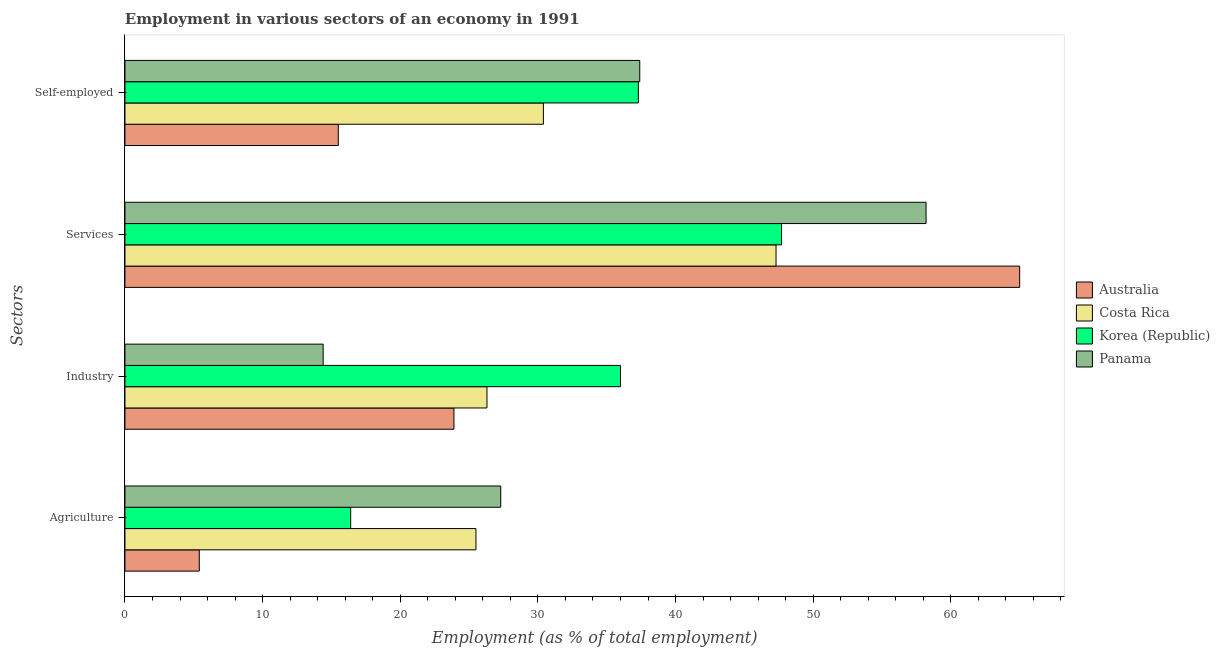How many different coloured bars are there?
Offer a terse response. 4. How many groups of bars are there?
Provide a short and direct response. 4. Are the number of bars on each tick of the Y-axis equal?
Your answer should be compact. Yes. How many bars are there on the 1st tick from the top?
Your response must be concise. 4. How many bars are there on the 1st tick from the bottom?
Your response must be concise. 4. What is the label of the 1st group of bars from the top?
Offer a very short reply. Self-employed. What is the percentage of self employed workers in Panama?
Your response must be concise. 37.4. In which country was the percentage of workers in industry minimum?
Provide a succinct answer. Panama. What is the total percentage of workers in agriculture in the graph?
Your response must be concise. 74.6. What is the difference between the percentage of workers in services in Australia and that in Korea (Republic)?
Your answer should be compact. 17.3. What is the difference between the percentage of workers in services in Costa Rica and the percentage of workers in industry in Australia?
Make the answer very short. 23.4. What is the average percentage of workers in industry per country?
Your response must be concise. 25.15. What is the difference between the percentage of workers in agriculture and percentage of workers in industry in Korea (Republic)?
Ensure brevity in your answer.  -19.6. What is the ratio of the percentage of workers in industry in Australia to that in Korea (Republic)?
Your response must be concise. 0.66. Is the percentage of workers in agriculture in Costa Rica less than that in Australia?
Your answer should be compact. No. Is the difference between the percentage of self employed workers in Australia and Costa Rica greater than the difference between the percentage of workers in agriculture in Australia and Costa Rica?
Ensure brevity in your answer.  Yes. What is the difference between the highest and the second highest percentage of workers in services?
Ensure brevity in your answer.  6.8. What is the difference between the highest and the lowest percentage of workers in industry?
Ensure brevity in your answer.  21.6. What does the 3rd bar from the top in Agriculture represents?
Your answer should be compact. Costa Rica. How many bars are there?
Provide a short and direct response. 16. Are the values on the major ticks of X-axis written in scientific E-notation?
Provide a short and direct response. No. How many legend labels are there?
Offer a terse response. 4. What is the title of the graph?
Your answer should be compact. Employment in various sectors of an economy in 1991. Does "Iran" appear as one of the legend labels in the graph?
Your answer should be compact. No. What is the label or title of the X-axis?
Offer a very short reply. Employment (as % of total employment). What is the label or title of the Y-axis?
Keep it short and to the point. Sectors. What is the Employment (as % of total employment) of Australia in Agriculture?
Provide a short and direct response. 5.4. What is the Employment (as % of total employment) of Costa Rica in Agriculture?
Provide a short and direct response. 25.5. What is the Employment (as % of total employment) of Korea (Republic) in Agriculture?
Your answer should be very brief. 16.4. What is the Employment (as % of total employment) of Panama in Agriculture?
Offer a very short reply. 27.3. What is the Employment (as % of total employment) in Australia in Industry?
Offer a very short reply. 23.9. What is the Employment (as % of total employment) of Costa Rica in Industry?
Provide a short and direct response. 26.3. What is the Employment (as % of total employment) of Korea (Republic) in Industry?
Your answer should be compact. 36. What is the Employment (as % of total employment) of Panama in Industry?
Offer a very short reply. 14.4. What is the Employment (as % of total employment) in Australia in Services?
Your answer should be compact. 65. What is the Employment (as % of total employment) of Costa Rica in Services?
Make the answer very short. 47.3. What is the Employment (as % of total employment) in Korea (Republic) in Services?
Offer a very short reply. 47.7. What is the Employment (as % of total employment) in Panama in Services?
Your response must be concise. 58.2. What is the Employment (as % of total employment) of Australia in Self-employed?
Your response must be concise. 15.5. What is the Employment (as % of total employment) of Costa Rica in Self-employed?
Keep it short and to the point. 30.4. What is the Employment (as % of total employment) in Korea (Republic) in Self-employed?
Ensure brevity in your answer.  37.3. What is the Employment (as % of total employment) of Panama in Self-employed?
Ensure brevity in your answer.  37.4. Across all Sectors, what is the maximum Employment (as % of total employment) in Costa Rica?
Offer a terse response. 47.3. Across all Sectors, what is the maximum Employment (as % of total employment) in Korea (Republic)?
Give a very brief answer. 47.7. Across all Sectors, what is the maximum Employment (as % of total employment) of Panama?
Keep it short and to the point. 58.2. Across all Sectors, what is the minimum Employment (as % of total employment) of Australia?
Offer a terse response. 5.4. Across all Sectors, what is the minimum Employment (as % of total employment) in Costa Rica?
Provide a short and direct response. 25.5. Across all Sectors, what is the minimum Employment (as % of total employment) of Korea (Republic)?
Keep it short and to the point. 16.4. Across all Sectors, what is the minimum Employment (as % of total employment) of Panama?
Offer a very short reply. 14.4. What is the total Employment (as % of total employment) of Australia in the graph?
Make the answer very short. 109.8. What is the total Employment (as % of total employment) of Costa Rica in the graph?
Provide a short and direct response. 129.5. What is the total Employment (as % of total employment) of Korea (Republic) in the graph?
Your response must be concise. 137.4. What is the total Employment (as % of total employment) in Panama in the graph?
Offer a very short reply. 137.3. What is the difference between the Employment (as % of total employment) of Australia in Agriculture and that in Industry?
Your response must be concise. -18.5. What is the difference between the Employment (as % of total employment) of Costa Rica in Agriculture and that in Industry?
Ensure brevity in your answer.  -0.8. What is the difference between the Employment (as % of total employment) in Korea (Republic) in Agriculture and that in Industry?
Keep it short and to the point. -19.6. What is the difference between the Employment (as % of total employment) in Panama in Agriculture and that in Industry?
Make the answer very short. 12.9. What is the difference between the Employment (as % of total employment) of Australia in Agriculture and that in Services?
Your response must be concise. -59.6. What is the difference between the Employment (as % of total employment) of Costa Rica in Agriculture and that in Services?
Provide a succinct answer. -21.8. What is the difference between the Employment (as % of total employment) in Korea (Republic) in Agriculture and that in Services?
Your answer should be compact. -31.3. What is the difference between the Employment (as % of total employment) of Panama in Agriculture and that in Services?
Ensure brevity in your answer.  -30.9. What is the difference between the Employment (as % of total employment) in Australia in Agriculture and that in Self-employed?
Keep it short and to the point. -10.1. What is the difference between the Employment (as % of total employment) of Korea (Republic) in Agriculture and that in Self-employed?
Make the answer very short. -20.9. What is the difference between the Employment (as % of total employment) of Australia in Industry and that in Services?
Offer a very short reply. -41.1. What is the difference between the Employment (as % of total employment) in Panama in Industry and that in Services?
Your answer should be compact. -43.8. What is the difference between the Employment (as % of total employment) in Panama in Industry and that in Self-employed?
Give a very brief answer. -23. What is the difference between the Employment (as % of total employment) of Australia in Services and that in Self-employed?
Your response must be concise. 49.5. What is the difference between the Employment (as % of total employment) of Korea (Republic) in Services and that in Self-employed?
Ensure brevity in your answer.  10.4. What is the difference between the Employment (as % of total employment) of Panama in Services and that in Self-employed?
Provide a succinct answer. 20.8. What is the difference between the Employment (as % of total employment) of Australia in Agriculture and the Employment (as % of total employment) of Costa Rica in Industry?
Give a very brief answer. -20.9. What is the difference between the Employment (as % of total employment) in Australia in Agriculture and the Employment (as % of total employment) in Korea (Republic) in Industry?
Give a very brief answer. -30.6. What is the difference between the Employment (as % of total employment) in Australia in Agriculture and the Employment (as % of total employment) in Panama in Industry?
Offer a terse response. -9. What is the difference between the Employment (as % of total employment) in Costa Rica in Agriculture and the Employment (as % of total employment) in Panama in Industry?
Provide a succinct answer. 11.1. What is the difference between the Employment (as % of total employment) in Korea (Republic) in Agriculture and the Employment (as % of total employment) in Panama in Industry?
Your response must be concise. 2. What is the difference between the Employment (as % of total employment) in Australia in Agriculture and the Employment (as % of total employment) in Costa Rica in Services?
Provide a short and direct response. -41.9. What is the difference between the Employment (as % of total employment) in Australia in Agriculture and the Employment (as % of total employment) in Korea (Republic) in Services?
Give a very brief answer. -42.3. What is the difference between the Employment (as % of total employment) of Australia in Agriculture and the Employment (as % of total employment) of Panama in Services?
Provide a succinct answer. -52.8. What is the difference between the Employment (as % of total employment) of Costa Rica in Agriculture and the Employment (as % of total employment) of Korea (Republic) in Services?
Offer a terse response. -22.2. What is the difference between the Employment (as % of total employment) of Costa Rica in Agriculture and the Employment (as % of total employment) of Panama in Services?
Your response must be concise. -32.7. What is the difference between the Employment (as % of total employment) in Korea (Republic) in Agriculture and the Employment (as % of total employment) in Panama in Services?
Make the answer very short. -41.8. What is the difference between the Employment (as % of total employment) in Australia in Agriculture and the Employment (as % of total employment) in Korea (Republic) in Self-employed?
Your answer should be compact. -31.9. What is the difference between the Employment (as % of total employment) of Australia in Agriculture and the Employment (as % of total employment) of Panama in Self-employed?
Your response must be concise. -32. What is the difference between the Employment (as % of total employment) of Costa Rica in Agriculture and the Employment (as % of total employment) of Korea (Republic) in Self-employed?
Offer a very short reply. -11.8. What is the difference between the Employment (as % of total employment) in Costa Rica in Agriculture and the Employment (as % of total employment) in Panama in Self-employed?
Offer a terse response. -11.9. What is the difference between the Employment (as % of total employment) of Korea (Republic) in Agriculture and the Employment (as % of total employment) of Panama in Self-employed?
Provide a short and direct response. -21. What is the difference between the Employment (as % of total employment) of Australia in Industry and the Employment (as % of total employment) of Costa Rica in Services?
Ensure brevity in your answer.  -23.4. What is the difference between the Employment (as % of total employment) of Australia in Industry and the Employment (as % of total employment) of Korea (Republic) in Services?
Your response must be concise. -23.8. What is the difference between the Employment (as % of total employment) in Australia in Industry and the Employment (as % of total employment) in Panama in Services?
Keep it short and to the point. -34.3. What is the difference between the Employment (as % of total employment) in Costa Rica in Industry and the Employment (as % of total employment) in Korea (Republic) in Services?
Provide a succinct answer. -21.4. What is the difference between the Employment (as % of total employment) of Costa Rica in Industry and the Employment (as % of total employment) of Panama in Services?
Your answer should be compact. -31.9. What is the difference between the Employment (as % of total employment) in Korea (Republic) in Industry and the Employment (as % of total employment) in Panama in Services?
Give a very brief answer. -22.2. What is the difference between the Employment (as % of total employment) of Australia in Industry and the Employment (as % of total employment) of Costa Rica in Self-employed?
Give a very brief answer. -6.5. What is the difference between the Employment (as % of total employment) in Australia in Industry and the Employment (as % of total employment) in Korea (Republic) in Self-employed?
Your response must be concise. -13.4. What is the difference between the Employment (as % of total employment) of Costa Rica in Industry and the Employment (as % of total employment) of Korea (Republic) in Self-employed?
Keep it short and to the point. -11. What is the difference between the Employment (as % of total employment) in Korea (Republic) in Industry and the Employment (as % of total employment) in Panama in Self-employed?
Your answer should be compact. -1.4. What is the difference between the Employment (as % of total employment) of Australia in Services and the Employment (as % of total employment) of Costa Rica in Self-employed?
Your answer should be compact. 34.6. What is the difference between the Employment (as % of total employment) of Australia in Services and the Employment (as % of total employment) of Korea (Republic) in Self-employed?
Offer a very short reply. 27.7. What is the difference between the Employment (as % of total employment) in Australia in Services and the Employment (as % of total employment) in Panama in Self-employed?
Your answer should be compact. 27.6. What is the difference between the Employment (as % of total employment) of Costa Rica in Services and the Employment (as % of total employment) of Panama in Self-employed?
Give a very brief answer. 9.9. What is the average Employment (as % of total employment) in Australia per Sectors?
Keep it short and to the point. 27.45. What is the average Employment (as % of total employment) of Costa Rica per Sectors?
Ensure brevity in your answer.  32.38. What is the average Employment (as % of total employment) in Korea (Republic) per Sectors?
Provide a short and direct response. 34.35. What is the average Employment (as % of total employment) in Panama per Sectors?
Your answer should be compact. 34.33. What is the difference between the Employment (as % of total employment) in Australia and Employment (as % of total employment) in Costa Rica in Agriculture?
Your answer should be very brief. -20.1. What is the difference between the Employment (as % of total employment) in Australia and Employment (as % of total employment) in Korea (Republic) in Agriculture?
Offer a terse response. -11. What is the difference between the Employment (as % of total employment) of Australia and Employment (as % of total employment) of Panama in Agriculture?
Make the answer very short. -21.9. What is the difference between the Employment (as % of total employment) of Costa Rica and Employment (as % of total employment) of Korea (Republic) in Agriculture?
Provide a succinct answer. 9.1. What is the difference between the Employment (as % of total employment) of Costa Rica and Employment (as % of total employment) of Panama in Agriculture?
Provide a succinct answer. -1.8. What is the difference between the Employment (as % of total employment) of Australia and Employment (as % of total employment) of Costa Rica in Industry?
Keep it short and to the point. -2.4. What is the difference between the Employment (as % of total employment) of Australia and Employment (as % of total employment) of Korea (Republic) in Industry?
Provide a short and direct response. -12.1. What is the difference between the Employment (as % of total employment) in Australia and Employment (as % of total employment) in Panama in Industry?
Keep it short and to the point. 9.5. What is the difference between the Employment (as % of total employment) of Costa Rica and Employment (as % of total employment) of Panama in Industry?
Ensure brevity in your answer.  11.9. What is the difference between the Employment (as % of total employment) in Korea (Republic) and Employment (as % of total employment) in Panama in Industry?
Keep it short and to the point. 21.6. What is the difference between the Employment (as % of total employment) in Australia and Employment (as % of total employment) in Costa Rica in Services?
Keep it short and to the point. 17.7. What is the difference between the Employment (as % of total employment) in Australia and Employment (as % of total employment) in Korea (Republic) in Services?
Make the answer very short. 17.3. What is the difference between the Employment (as % of total employment) in Australia and Employment (as % of total employment) in Panama in Services?
Your answer should be compact. 6.8. What is the difference between the Employment (as % of total employment) in Costa Rica and Employment (as % of total employment) in Korea (Republic) in Services?
Ensure brevity in your answer.  -0.4. What is the difference between the Employment (as % of total employment) of Costa Rica and Employment (as % of total employment) of Panama in Services?
Offer a terse response. -10.9. What is the difference between the Employment (as % of total employment) of Korea (Republic) and Employment (as % of total employment) of Panama in Services?
Make the answer very short. -10.5. What is the difference between the Employment (as % of total employment) of Australia and Employment (as % of total employment) of Costa Rica in Self-employed?
Give a very brief answer. -14.9. What is the difference between the Employment (as % of total employment) in Australia and Employment (as % of total employment) in Korea (Republic) in Self-employed?
Offer a very short reply. -21.8. What is the difference between the Employment (as % of total employment) in Australia and Employment (as % of total employment) in Panama in Self-employed?
Provide a short and direct response. -21.9. What is the difference between the Employment (as % of total employment) of Costa Rica and Employment (as % of total employment) of Panama in Self-employed?
Provide a short and direct response. -7. What is the ratio of the Employment (as % of total employment) of Australia in Agriculture to that in Industry?
Provide a short and direct response. 0.23. What is the ratio of the Employment (as % of total employment) of Costa Rica in Agriculture to that in Industry?
Make the answer very short. 0.97. What is the ratio of the Employment (as % of total employment) in Korea (Republic) in Agriculture to that in Industry?
Your response must be concise. 0.46. What is the ratio of the Employment (as % of total employment) of Panama in Agriculture to that in Industry?
Ensure brevity in your answer.  1.9. What is the ratio of the Employment (as % of total employment) of Australia in Agriculture to that in Services?
Offer a very short reply. 0.08. What is the ratio of the Employment (as % of total employment) of Costa Rica in Agriculture to that in Services?
Your answer should be very brief. 0.54. What is the ratio of the Employment (as % of total employment) in Korea (Republic) in Agriculture to that in Services?
Make the answer very short. 0.34. What is the ratio of the Employment (as % of total employment) in Panama in Agriculture to that in Services?
Your response must be concise. 0.47. What is the ratio of the Employment (as % of total employment) in Australia in Agriculture to that in Self-employed?
Your response must be concise. 0.35. What is the ratio of the Employment (as % of total employment) of Costa Rica in Agriculture to that in Self-employed?
Your response must be concise. 0.84. What is the ratio of the Employment (as % of total employment) of Korea (Republic) in Agriculture to that in Self-employed?
Offer a very short reply. 0.44. What is the ratio of the Employment (as % of total employment) in Panama in Agriculture to that in Self-employed?
Offer a very short reply. 0.73. What is the ratio of the Employment (as % of total employment) of Australia in Industry to that in Services?
Offer a very short reply. 0.37. What is the ratio of the Employment (as % of total employment) of Costa Rica in Industry to that in Services?
Provide a succinct answer. 0.56. What is the ratio of the Employment (as % of total employment) in Korea (Republic) in Industry to that in Services?
Your response must be concise. 0.75. What is the ratio of the Employment (as % of total employment) of Panama in Industry to that in Services?
Make the answer very short. 0.25. What is the ratio of the Employment (as % of total employment) in Australia in Industry to that in Self-employed?
Offer a terse response. 1.54. What is the ratio of the Employment (as % of total employment) of Costa Rica in Industry to that in Self-employed?
Ensure brevity in your answer.  0.87. What is the ratio of the Employment (as % of total employment) in Korea (Republic) in Industry to that in Self-employed?
Your response must be concise. 0.97. What is the ratio of the Employment (as % of total employment) of Panama in Industry to that in Self-employed?
Provide a succinct answer. 0.39. What is the ratio of the Employment (as % of total employment) in Australia in Services to that in Self-employed?
Provide a short and direct response. 4.19. What is the ratio of the Employment (as % of total employment) of Costa Rica in Services to that in Self-employed?
Give a very brief answer. 1.56. What is the ratio of the Employment (as % of total employment) in Korea (Republic) in Services to that in Self-employed?
Your answer should be very brief. 1.28. What is the ratio of the Employment (as % of total employment) of Panama in Services to that in Self-employed?
Give a very brief answer. 1.56. What is the difference between the highest and the second highest Employment (as % of total employment) of Australia?
Your answer should be compact. 41.1. What is the difference between the highest and the second highest Employment (as % of total employment) in Panama?
Offer a very short reply. 20.8. What is the difference between the highest and the lowest Employment (as % of total employment) of Australia?
Your response must be concise. 59.6. What is the difference between the highest and the lowest Employment (as % of total employment) of Costa Rica?
Your response must be concise. 21.8. What is the difference between the highest and the lowest Employment (as % of total employment) of Korea (Republic)?
Give a very brief answer. 31.3. What is the difference between the highest and the lowest Employment (as % of total employment) in Panama?
Make the answer very short. 43.8. 